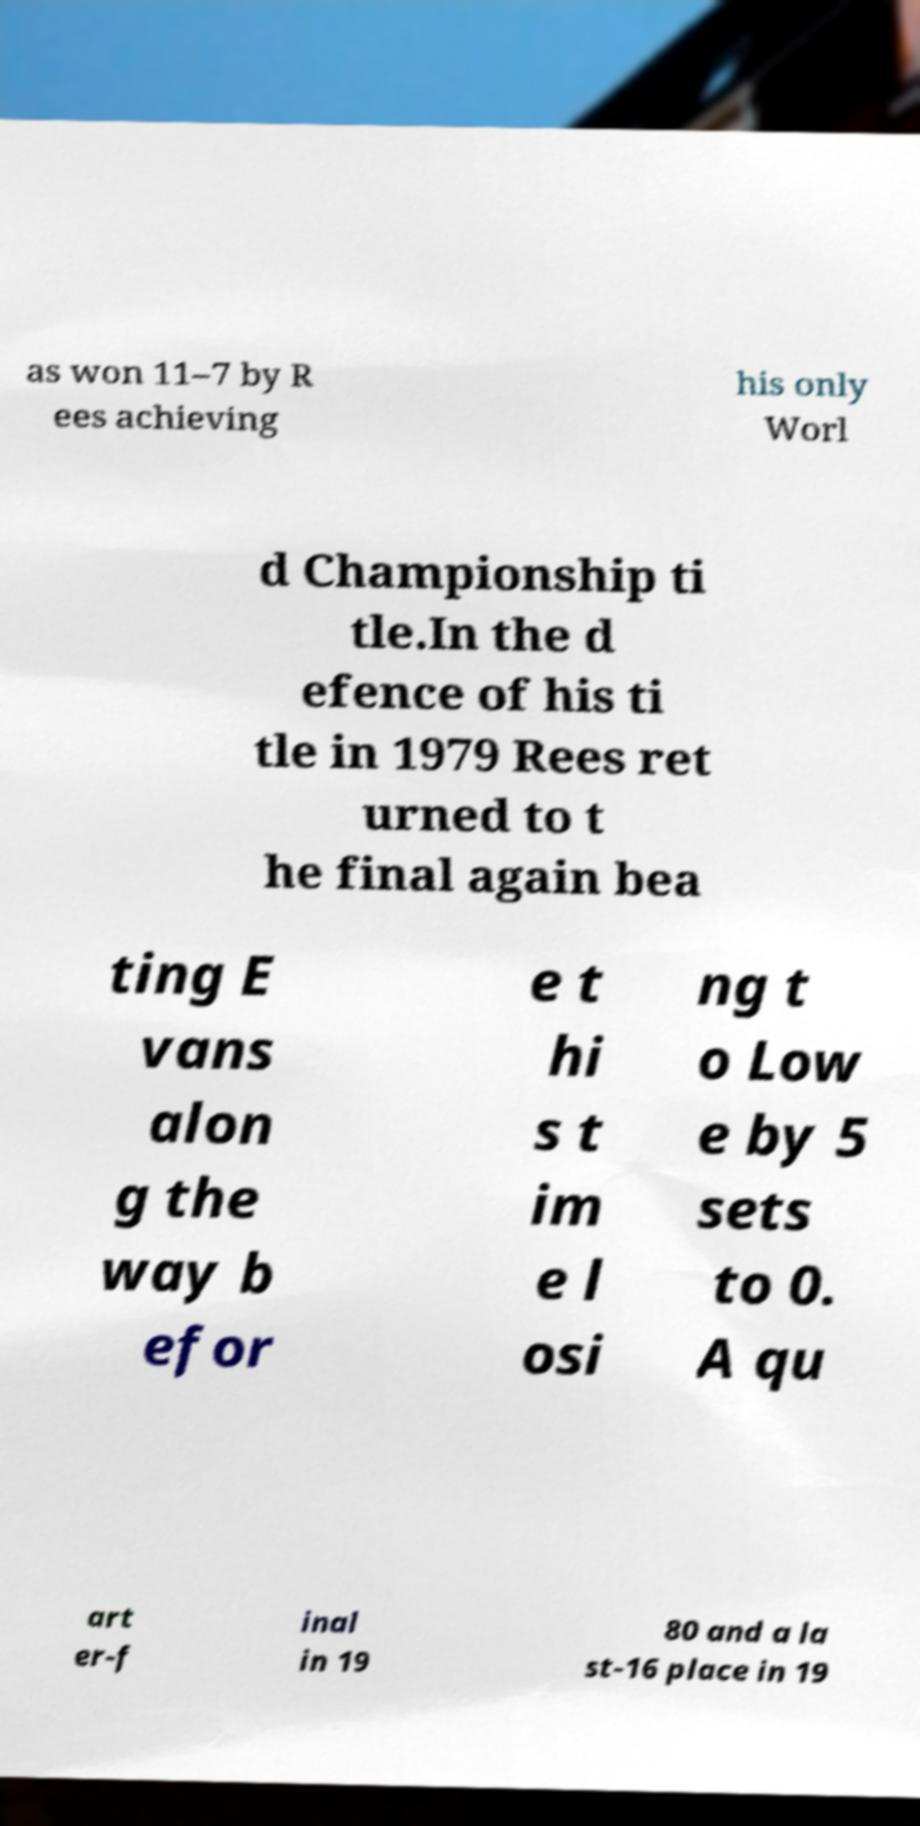Could you assist in decoding the text presented in this image and type it out clearly? as won 11–7 by R ees achieving his only Worl d Championship ti tle.In the d efence of his ti tle in 1979 Rees ret urned to t he final again bea ting E vans alon g the way b efor e t hi s t im e l osi ng t o Low e by 5 sets to 0. A qu art er-f inal in 19 80 and a la st-16 place in 19 